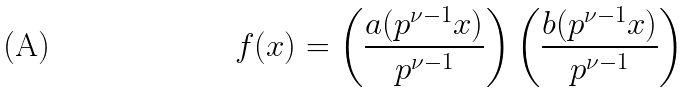Convert formula to latex. <formula><loc_0><loc_0><loc_500><loc_500>\ f ( x ) = \left ( \frac { a ( p ^ { \nu - 1 } x ) } { p ^ { \nu - 1 } } \right ) \left ( \frac { b ( p ^ { \nu - 1 } x ) } { p ^ { \nu - 1 } } \right )</formula> 